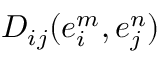Convert formula to latex. <formula><loc_0><loc_0><loc_500><loc_500>D _ { i j } ( e _ { i } ^ { m } , e _ { j } ^ { n } )</formula> 